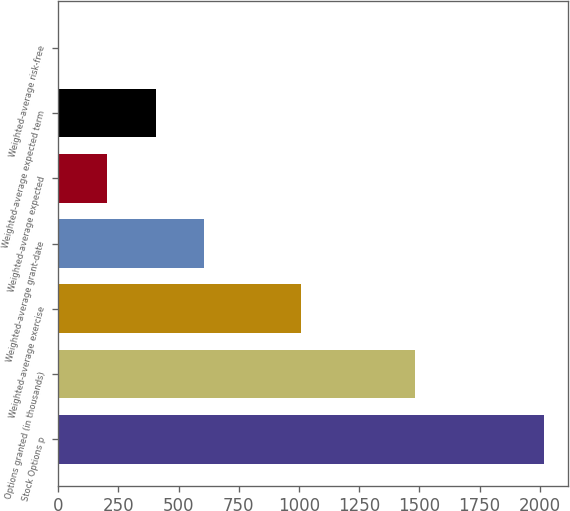Convert chart to OTSL. <chart><loc_0><loc_0><loc_500><loc_500><bar_chart><fcel>Stock Options p<fcel>Options granted (in thousands)<fcel>Weighted-average exercise<fcel>Weighted-average grant-date<fcel>Weighted-average expected<fcel>Weighted-average expected term<fcel>Weighted-average risk-free<nl><fcel>2017<fcel>1480<fcel>1009.55<fcel>606.57<fcel>203.59<fcel>405.08<fcel>2.1<nl></chart> 